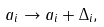Convert formula to latex. <formula><loc_0><loc_0><loc_500><loc_500>a _ { i } \rightarrow a _ { i } + \Delta _ { i } ,</formula> 